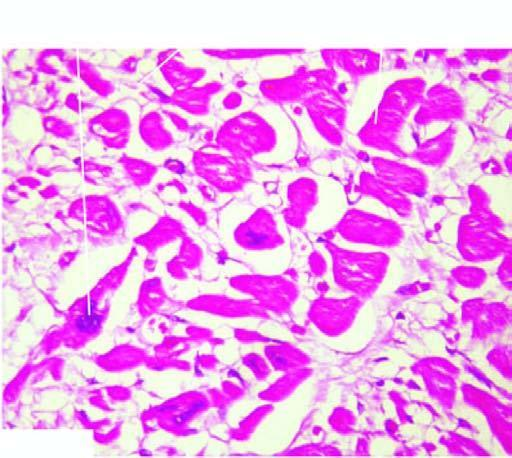re nuclei also enlarged with irregular outlines?
Answer the question using a single word or phrase. Yes 